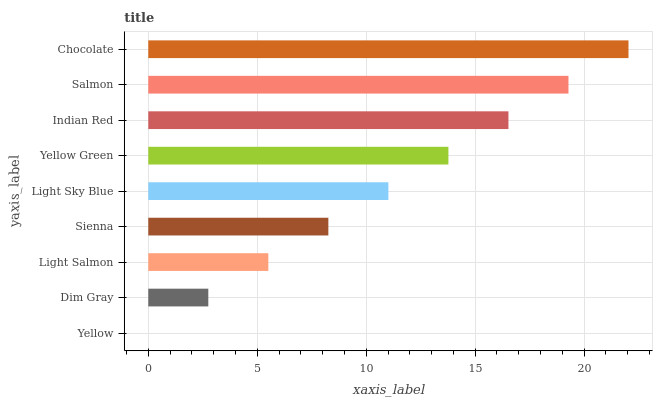Is Yellow the minimum?
Answer yes or no. Yes. Is Chocolate the maximum?
Answer yes or no. Yes. Is Dim Gray the minimum?
Answer yes or no. No. Is Dim Gray the maximum?
Answer yes or no. No. Is Dim Gray greater than Yellow?
Answer yes or no. Yes. Is Yellow less than Dim Gray?
Answer yes or no. Yes. Is Yellow greater than Dim Gray?
Answer yes or no. No. Is Dim Gray less than Yellow?
Answer yes or no. No. Is Light Sky Blue the high median?
Answer yes or no. Yes. Is Light Sky Blue the low median?
Answer yes or no. Yes. Is Dim Gray the high median?
Answer yes or no. No. Is Yellow the low median?
Answer yes or no. No. 